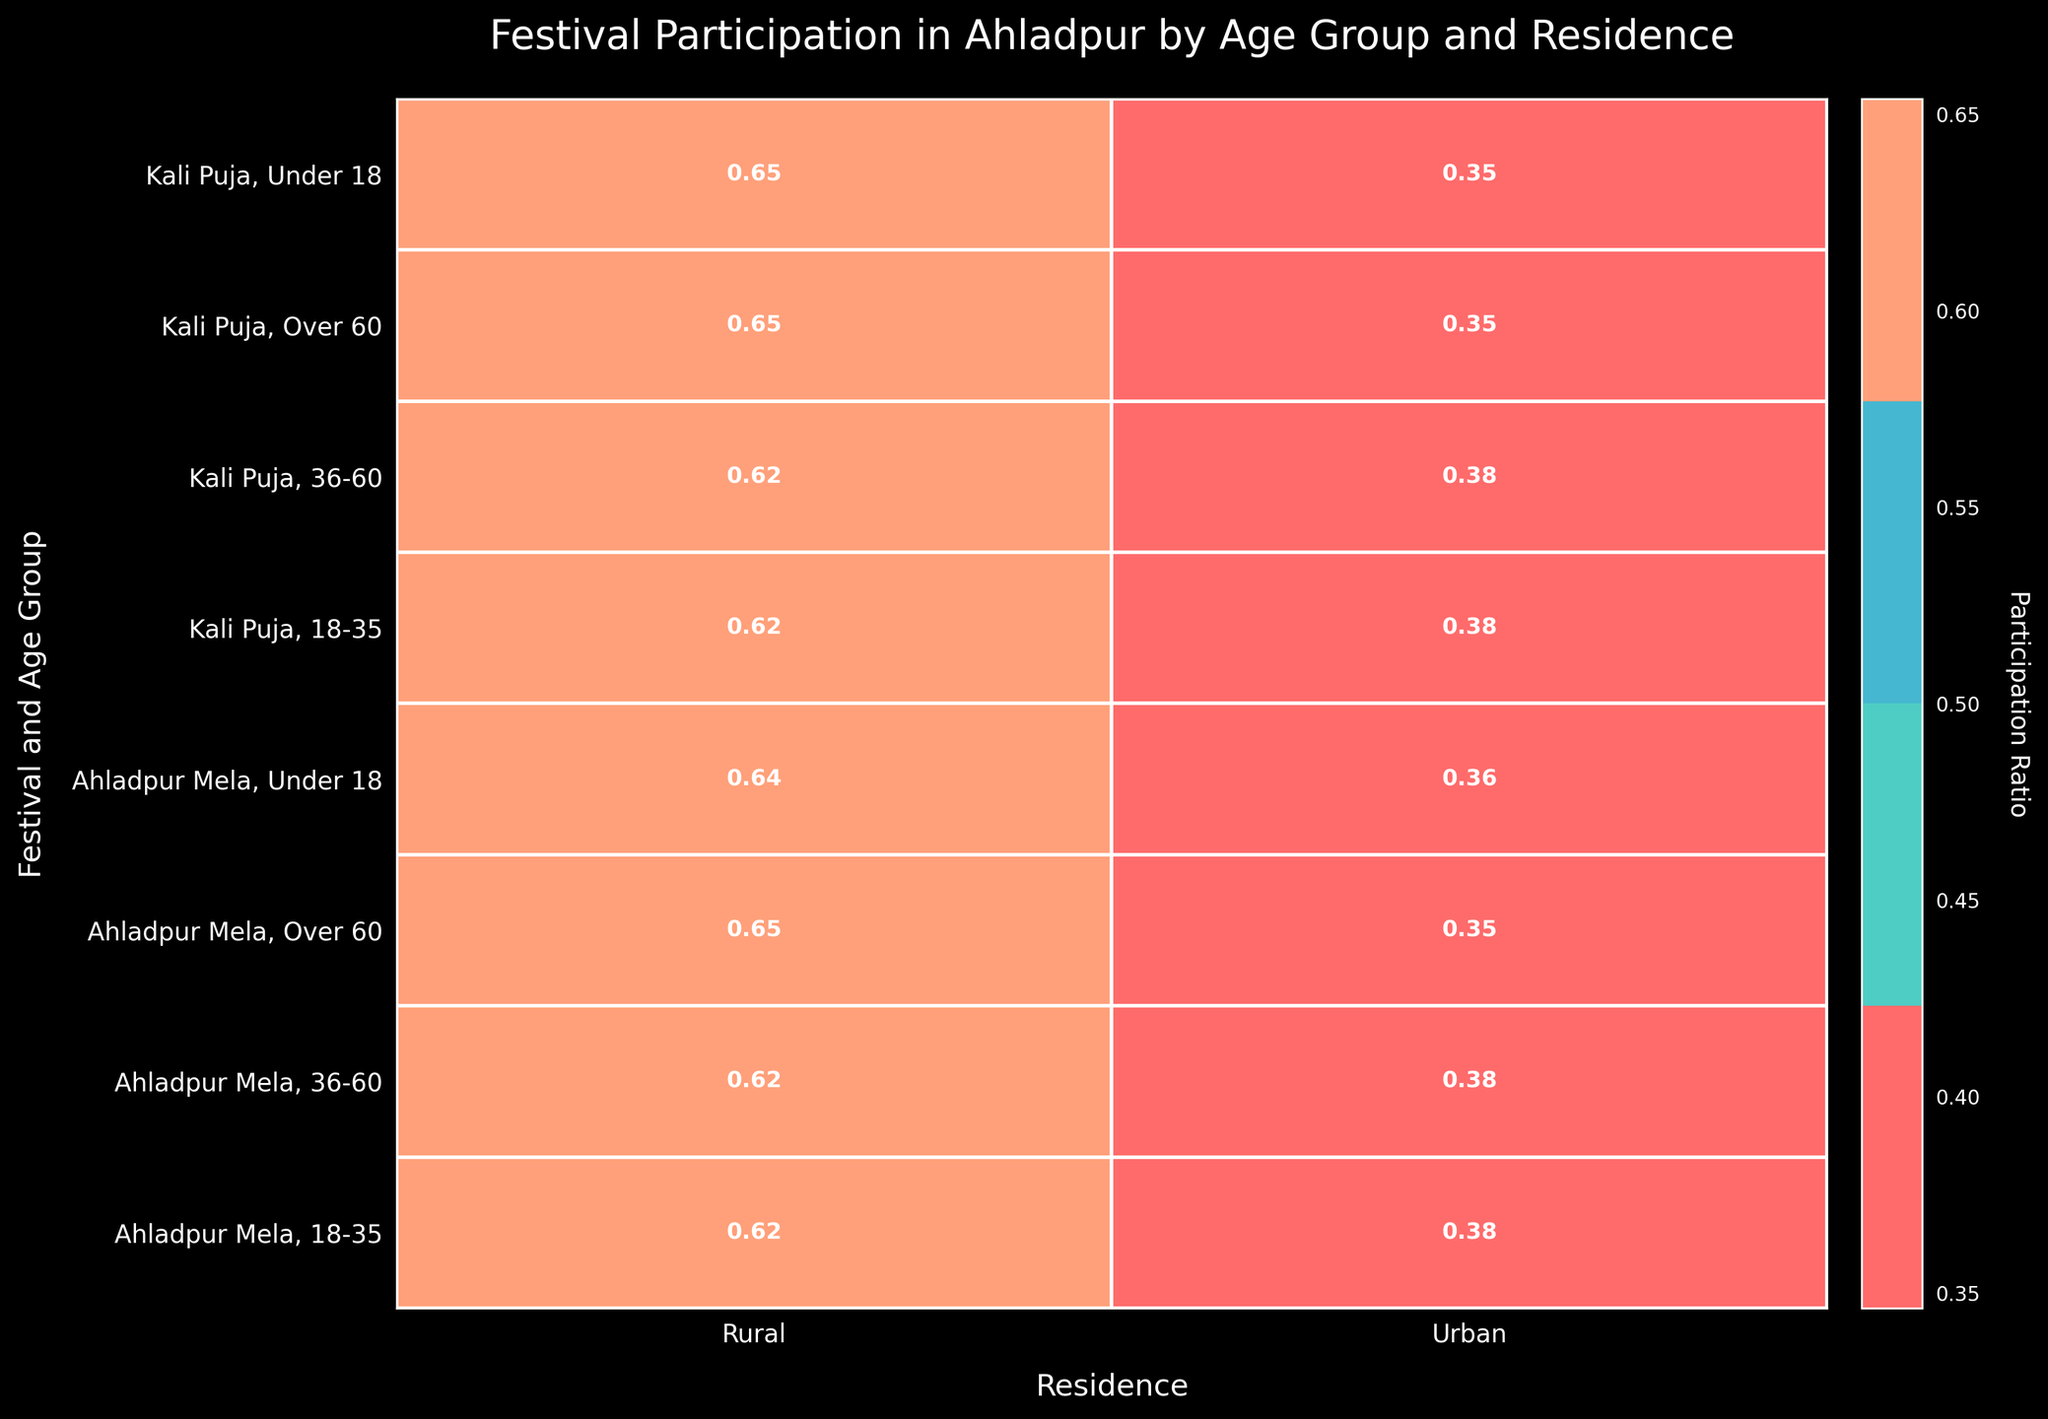What is the title of the mosaic plot? The title of the mosaic plot is found at the top of the figure. It summarizes the main subject of the plot.
Answer: Festival Participation in Ahladpur by Age Group and Residence What color represents rural area participation? To determine the color representing rural area participation, look at the color legend or directly at the plot where the columns for 'Rural' and 'Urban' are distinctively colored.
Answer: One of the colors like greenish or bluish hues Which age group has the highest participation ratio in the Ahladpur Mela for rural residents? Look at the rows corresponding to Ahladpur Mela and find the cell with the highest ratio for 'Rural' residence. Check the age group associated with that cell.
Answer: 18-35 In which festival do urban residents under 18 participate more frequently? Compare the participation ratios of urban residents under 18 in the Ahladpur Mela and Kali Puja rows. The higher ratio indicates more frequent participation.
Answer: Ahladpur Mela What is the participation ratio of rural residents aged 36-60 in Kali Puja? Locate the row for Kali Puja and the age group 36-60, then find the corresponding cell in the 'Rural' column and read the ratio value.
Answer: Approximately 0.62 Which residence type has a higher participation ratio for the festival Kali Puja in the 18-35 age group? Look at the cells in the row for Kali Puja and the 18-35 age group, and compare the ratios for 'Urban' and 'Rural' residence types.
Answer: Rural For the Ahladpur Mela, which age group has the lowest participation ratio among urban residents? Locate the rows for Ahladpur Mela and compare the ratio values for 'Urban' residents across different age groups to find the lowest one.
Answer: Over 60 How does the participation ratio of urban residents in the Over 60 age group compare between Ahladpur Mela and Kali Puja? Compare the ratio values in the 'Urban' column for the Over 60 age group between the two festival rows. Determine which ratio is higher or if they are equal.
Answer: Higher in Ahladpur Mela What is the sum of participation ratios for rural residents across all age groups in Ahladpur Mela? Add the participation ratios from the 'Rural' column for all age groups in the Ahladpur Mela row. Since each ratio is normalized, the sum should be considered in context.
Answer: Sum should be close to 1 (since it's normalized) 